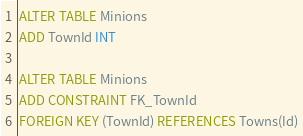Convert code to text. <code><loc_0><loc_0><loc_500><loc_500><_SQL_>ALTER TABLE Minions
ADD TownId INT

ALTER TABLE Minions
ADD CONSTRAINT FK_TownId
FOREIGN KEY (TownId) REFERENCES Towns(Id)</code> 